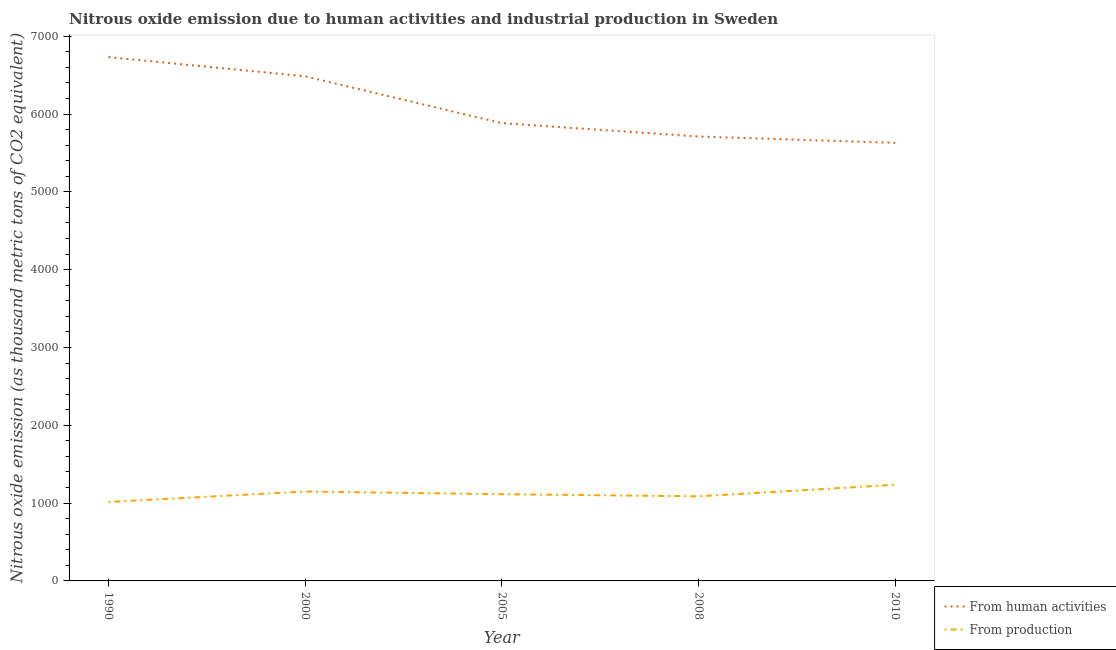How many different coloured lines are there?
Your response must be concise. 2. What is the amount of emissions generated from industries in 2010?
Provide a succinct answer. 1235.9. Across all years, what is the maximum amount of emissions generated from industries?
Give a very brief answer. 1235.9. Across all years, what is the minimum amount of emissions from human activities?
Keep it short and to the point. 5629.4. What is the total amount of emissions generated from industries in the graph?
Your answer should be very brief. 5601.6. What is the difference between the amount of emissions generated from industries in 2005 and that in 2010?
Your answer should be very brief. -121.1. What is the difference between the amount of emissions from human activities in 2005 and the amount of emissions generated from industries in 2000?
Your answer should be compact. 4733.9. What is the average amount of emissions generated from industries per year?
Ensure brevity in your answer.  1120.32. In the year 1990, what is the difference between the amount of emissions from human activities and amount of emissions generated from industries?
Your answer should be very brief. 5716.6. In how many years, is the amount of emissions from human activities greater than 2200 thousand metric tons?
Give a very brief answer. 5. What is the ratio of the amount of emissions generated from industries in 1990 to that in 2000?
Ensure brevity in your answer.  0.88. Is the difference between the amount of emissions from human activities in 2008 and 2010 greater than the difference between the amount of emissions generated from industries in 2008 and 2010?
Give a very brief answer. Yes. What is the difference between the highest and the second highest amount of emissions generated from industries?
Make the answer very short. 87.1. What is the difference between the highest and the lowest amount of emissions from human activities?
Make the answer very short. 1102. Is the sum of the amount of emissions from human activities in 2000 and 2010 greater than the maximum amount of emissions generated from industries across all years?
Your answer should be very brief. Yes. Is the amount of emissions generated from industries strictly greater than the amount of emissions from human activities over the years?
Keep it short and to the point. No. Is the amount of emissions from human activities strictly less than the amount of emissions generated from industries over the years?
Ensure brevity in your answer.  No. How many years are there in the graph?
Offer a terse response. 5. What is the difference between two consecutive major ticks on the Y-axis?
Your answer should be compact. 1000. Are the values on the major ticks of Y-axis written in scientific E-notation?
Your answer should be compact. No. Where does the legend appear in the graph?
Your answer should be compact. Bottom right. What is the title of the graph?
Provide a short and direct response. Nitrous oxide emission due to human activities and industrial production in Sweden. Does "Forest" appear as one of the legend labels in the graph?
Provide a succinct answer. No. What is the label or title of the X-axis?
Give a very brief answer. Year. What is the label or title of the Y-axis?
Ensure brevity in your answer.  Nitrous oxide emission (as thousand metric tons of CO2 equivalent). What is the Nitrous oxide emission (as thousand metric tons of CO2 equivalent) of From human activities in 1990?
Provide a succinct answer. 6731.4. What is the Nitrous oxide emission (as thousand metric tons of CO2 equivalent) of From production in 1990?
Give a very brief answer. 1014.8. What is the Nitrous oxide emission (as thousand metric tons of CO2 equivalent) of From human activities in 2000?
Ensure brevity in your answer.  6484.9. What is the Nitrous oxide emission (as thousand metric tons of CO2 equivalent) of From production in 2000?
Offer a very short reply. 1148.8. What is the Nitrous oxide emission (as thousand metric tons of CO2 equivalent) of From human activities in 2005?
Offer a terse response. 5882.7. What is the Nitrous oxide emission (as thousand metric tons of CO2 equivalent) in From production in 2005?
Your response must be concise. 1114.8. What is the Nitrous oxide emission (as thousand metric tons of CO2 equivalent) in From human activities in 2008?
Your answer should be very brief. 5711. What is the Nitrous oxide emission (as thousand metric tons of CO2 equivalent) of From production in 2008?
Your answer should be very brief. 1087.3. What is the Nitrous oxide emission (as thousand metric tons of CO2 equivalent) in From human activities in 2010?
Offer a very short reply. 5629.4. What is the Nitrous oxide emission (as thousand metric tons of CO2 equivalent) of From production in 2010?
Your response must be concise. 1235.9. Across all years, what is the maximum Nitrous oxide emission (as thousand metric tons of CO2 equivalent) of From human activities?
Your answer should be compact. 6731.4. Across all years, what is the maximum Nitrous oxide emission (as thousand metric tons of CO2 equivalent) of From production?
Keep it short and to the point. 1235.9. Across all years, what is the minimum Nitrous oxide emission (as thousand metric tons of CO2 equivalent) in From human activities?
Give a very brief answer. 5629.4. Across all years, what is the minimum Nitrous oxide emission (as thousand metric tons of CO2 equivalent) of From production?
Offer a very short reply. 1014.8. What is the total Nitrous oxide emission (as thousand metric tons of CO2 equivalent) in From human activities in the graph?
Your response must be concise. 3.04e+04. What is the total Nitrous oxide emission (as thousand metric tons of CO2 equivalent) of From production in the graph?
Offer a very short reply. 5601.6. What is the difference between the Nitrous oxide emission (as thousand metric tons of CO2 equivalent) in From human activities in 1990 and that in 2000?
Your answer should be very brief. 246.5. What is the difference between the Nitrous oxide emission (as thousand metric tons of CO2 equivalent) of From production in 1990 and that in 2000?
Ensure brevity in your answer.  -134. What is the difference between the Nitrous oxide emission (as thousand metric tons of CO2 equivalent) in From human activities in 1990 and that in 2005?
Ensure brevity in your answer.  848.7. What is the difference between the Nitrous oxide emission (as thousand metric tons of CO2 equivalent) of From production in 1990 and that in 2005?
Provide a succinct answer. -100. What is the difference between the Nitrous oxide emission (as thousand metric tons of CO2 equivalent) of From human activities in 1990 and that in 2008?
Offer a very short reply. 1020.4. What is the difference between the Nitrous oxide emission (as thousand metric tons of CO2 equivalent) of From production in 1990 and that in 2008?
Give a very brief answer. -72.5. What is the difference between the Nitrous oxide emission (as thousand metric tons of CO2 equivalent) in From human activities in 1990 and that in 2010?
Offer a very short reply. 1102. What is the difference between the Nitrous oxide emission (as thousand metric tons of CO2 equivalent) in From production in 1990 and that in 2010?
Offer a terse response. -221.1. What is the difference between the Nitrous oxide emission (as thousand metric tons of CO2 equivalent) of From human activities in 2000 and that in 2005?
Ensure brevity in your answer.  602.2. What is the difference between the Nitrous oxide emission (as thousand metric tons of CO2 equivalent) of From production in 2000 and that in 2005?
Your response must be concise. 34. What is the difference between the Nitrous oxide emission (as thousand metric tons of CO2 equivalent) of From human activities in 2000 and that in 2008?
Offer a terse response. 773.9. What is the difference between the Nitrous oxide emission (as thousand metric tons of CO2 equivalent) of From production in 2000 and that in 2008?
Provide a succinct answer. 61.5. What is the difference between the Nitrous oxide emission (as thousand metric tons of CO2 equivalent) in From human activities in 2000 and that in 2010?
Provide a short and direct response. 855.5. What is the difference between the Nitrous oxide emission (as thousand metric tons of CO2 equivalent) in From production in 2000 and that in 2010?
Give a very brief answer. -87.1. What is the difference between the Nitrous oxide emission (as thousand metric tons of CO2 equivalent) of From human activities in 2005 and that in 2008?
Offer a terse response. 171.7. What is the difference between the Nitrous oxide emission (as thousand metric tons of CO2 equivalent) of From production in 2005 and that in 2008?
Provide a short and direct response. 27.5. What is the difference between the Nitrous oxide emission (as thousand metric tons of CO2 equivalent) in From human activities in 2005 and that in 2010?
Your answer should be very brief. 253.3. What is the difference between the Nitrous oxide emission (as thousand metric tons of CO2 equivalent) in From production in 2005 and that in 2010?
Give a very brief answer. -121.1. What is the difference between the Nitrous oxide emission (as thousand metric tons of CO2 equivalent) of From human activities in 2008 and that in 2010?
Your response must be concise. 81.6. What is the difference between the Nitrous oxide emission (as thousand metric tons of CO2 equivalent) in From production in 2008 and that in 2010?
Keep it short and to the point. -148.6. What is the difference between the Nitrous oxide emission (as thousand metric tons of CO2 equivalent) in From human activities in 1990 and the Nitrous oxide emission (as thousand metric tons of CO2 equivalent) in From production in 2000?
Your response must be concise. 5582.6. What is the difference between the Nitrous oxide emission (as thousand metric tons of CO2 equivalent) in From human activities in 1990 and the Nitrous oxide emission (as thousand metric tons of CO2 equivalent) in From production in 2005?
Offer a very short reply. 5616.6. What is the difference between the Nitrous oxide emission (as thousand metric tons of CO2 equivalent) of From human activities in 1990 and the Nitrous oxide emission (as thousand metric tons of CO2 equivalent) of From production in 2008?
Offer a terse response. 5644.1. What is the difference between the Nitrous oxide emission (as thousand metric tons of CO2 equivalent) in From human activities in 1990 and the Nitrous oxide emission (as thousand metric tons of CO2 equivalent) in From production in 2010?
Your answer should be compact. 5495.5. What is the difference between the Nitrous oxide emission (as thousand metric tons of CO2 equivalent) in From human activities in 2000 and the Nitrous oxide emission (as thousand metric tons of CO2 equivalent) in From production in 2005?
Ensure brevity in your answer.  5370.1. What is the difference between the Nitrous oxide emission (as thousand metric tons of CO2 equivalent) in From human activities in 2000 and the Nitrous oxide emission (as thousand metric tons of CO2 equivalent) in From production in 2008?
Offer a very short reply. 5397.6. What is the difference between the Nitrous oxide emission (as thousand metric tons of CO2 equivalent) in From human activities in 2000 and the Nitrous oxide emission (as thousand metric tons of CO2 equivalent) in From production in 2010?
Ensure brevity in your answer.  5249. What is the difference between the Nitrous oxide emission (as thousand metric tons of CO2 equivalent) in From human activities in 2005 and the Nitrous oxide emission (as thousand metric tons of CO2 equivalent) in From production in 2008?
Your response must be concise. 4795.4. What is the difference between the Nitrous oxide emission (as thousand metric tons of CO2 equivalent) of From human activities in 2005 and the Nitrous oxide emission (as thousand metric tons of CO2 equivalent) of From production in 2010?
Your answer should be compact. 4646.8. What is the difference between the Nitrous oxide emission (as thousand metric tons of CO2 equivalent) in From human activities in 2008 and the Nitrous oxide emission (as thousand metric tons of CO2 equivalent) in From production in 2010?
Your response must be concise. 4475.1. What is the average Nitrous oxide emission (as thousand metric tons of CO2 equivalent) of From human activities per year?
Ensure brevity in your answer.  6087.88. What is the average Nitrous oxide emission (as thousand metric tons of CO2 equivalent) of From production per year?
Make the answer very short. 1120.32. In the year 1990, what is the difference between the Nitrous oxide emission (as thousand metric tons of CO2 equivalent) in From human activities and Nitrous oxide emission (as thousand metric tons of CO2 equivalent) in From production?
Ensure brevity in your answer.  5716.6. In the year 2000, what is the difference between the Nitrous oxide emission (as thousand metric tons of CO2 equivalent) of From human activities and Nitrous oxide emission (as thousand metric tons of CO2 equivalent) of From production?
Offer a terse response. 5336.1. In the year 2005, what is the difference between the Nitrous oxide emission (as thousand metric tons of CO2 equivalent) of From human activities and Nitrous oxide emission (as thousand metric tons of CO2 equivalent) of From production?
Your answer should be compact. 4767.9. In the year 2008, what is the difference between the Nitrous oxide emission (as thousand metric tons of CO2 equivalent) in From human activities and Nitrous oxide emission (as thousand metric tons of CO2 equivalent) in From production?
Offer a very short reply. 4623.7. In the year 2010, what is the difference between the Nitrous oxide emission (as thousand metric tons of CO2 equivalent) of From human activities and Nitrous oxide emission (as thousand metric tons of CO2 equivalent) of From production?
Keep it short and to the point. 4393.5. What is the ratio of the Nitrous oxide emission (as thousand metric tons of CO2 equivalent) of From human activities in 1990 to that in 2000?
Your answer should be compact. 1.04. What is the ratio of the Nitrous oxide emission (as thousand metric tons of CO2 equivalent) of From production in 1990 to that in 2000?
Offer a very short reply. 0.88. What is the ratio of the Nitrous oxide emission (as thousand metric tons of CO2 equivalent) in From human activities in 1990 to that in 2005?
Keep it short and to the point. 1.14. What is the ratio of the Nitrous oxide emission (as thousand metric tons of CO2 equivalent) in From production in 1990 to that in 2005?
Your response must be concise. 0.91. What is the ratio of the Nitrous oxide emission (as thousand metric tons of CO2 equivalent) of From human activities in 1990 to that in 2008?
Make the answer very short. 1.18. What is the ratio of the Nitrous oxide emission (as thousand metric tons of CO2 equivalent) in From production in 1990 to that in 2008?
Make the answer very short. 0.93. What is the ratio of the Nitrous oxide emission (as thousand metric tons of CO2 equivalent) in From human activities in 1990 to that in 2010?
Provide a short and direct response. 1.2. What is the ratio of the Nitrous oxide emission (as thousand metric tons of CO2 equivalent) in From production in 1990 to that in 2010?
Offer a very short reply. 0.82. What is the ratio of the Nitrous oxide emission (as thousand metric tons of CO2 equivalent) in From human activities in 2000 to that in 2005?
Offer a terse response. 1.1. What is the ratio of the Nitrous oxide emission (as thousand metric tons of CO2 equivalent) in From production in 2000 to that in 2005?
Your response must be concise. 1.03. What is the ratio of the Nitrous oxide emission (as thousand metric tons of CO2 equivalent) of From human activities in 2000 to that in 2008?
Make the answer very short. 1.14. What is the ratio of the Nitrous oxide emission (as thousand metric tons of CO2 equivalent) in From production in 2000 to that in 2008?
Your answer should be very brief. 1.06. What is the ratio of the Nitrous oxide emission (as thousand metric tons of CO2 equivalent) of From human activities in 2000 to that in 2010?
Your answer should be very brief. 1.15. What is the ratio of the Nitrous oxide emission (as thousand metric tons of CO2 equivalent) in From production in 2000 to that in 2010?
Give a very brief answer. 0.93. What is the ratio of the Nitrous oxide emission (as thousand metric tons of CO2 equivalent) of From human activities in 2005 to that in 2008?
Your answer should be very brief. 1.03. What is the ratio of the Nitrous oxide emission (as thousand metric tons of CO2 equivalent) in From production in 2005 to that in 2008?
Give a very brief answer. 1.03. What is the ratio of the Nitrous oxide emission (as thousand metric tons of CO2 equivalent) in From human activities in 2005 to that in 2010?
Give a very brief answer. 1.04. What is the ratio of the Nitrous oxide emission (as thousand metric tons of CO2 equivalent) in From production in 2005 to that in 2010?
Your answer should be compact. 0.9. What is the ratio of the Nitrous oxide emission (as thousand metric tons of CO2 equivalent) in From human activities in 2008 to that in 2010?
Offer a terse response. 1.01. What is the ratio of the Nitrous oxide emission (as thousand metric tons of CO2 equivalent) of From production in 2008 to that in 2010?
Provide a short and direct response. 0.88. What is the difference between the highest and the second highest Nitrous oxide emission (as thousand metric tons of CO2 equivalent) of From human activities?
Offer a terse response. 246.5. What is the difference between the highest and the second highest Nitrous oxide emission (as thousand metric tons of CO2 equivalent) of From production?
Your answer should be compact. 87.1. What is the difference between the highest and the lowest Nitrous oxide emission (as thousand metric tons of CO2 equivalent) of From human activities?
Your answer should be very brief. 1102. What is the difference between the highest and the lowest Nitrous oxide emission (as thousand metric tons of CO2 equivalent) in From production?
Your answer should be very brief. 221.1. 